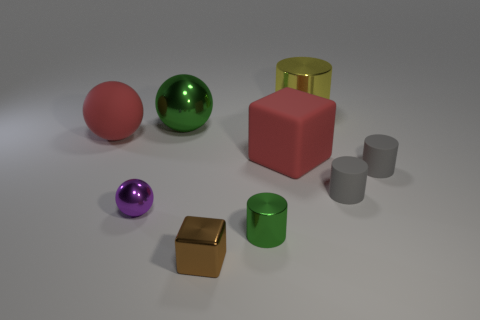Subtract all tiny green cylinders. How many cylinders are left? 3 Add 1 red cubes. How many objects exist? 10 Subtract all brown blocks. How many blocks are left? 1 Subtract 2 cylinders. How many cylinders are left? 2 Subtract all purple blocks. How many gray cylinders are left? 2 Subtract all cubes. How many objects are left? 7 Subtract 0 blue balls. How many objects are left? 9 Subtract all green balls. Subtract all gray cubes. How many balls are left? 2 Subtract all gray objects. Subtract all big red blocks. How many objects are left? 6 Add 1 tiny cylinders. How many tiny cylinders are left? 4 